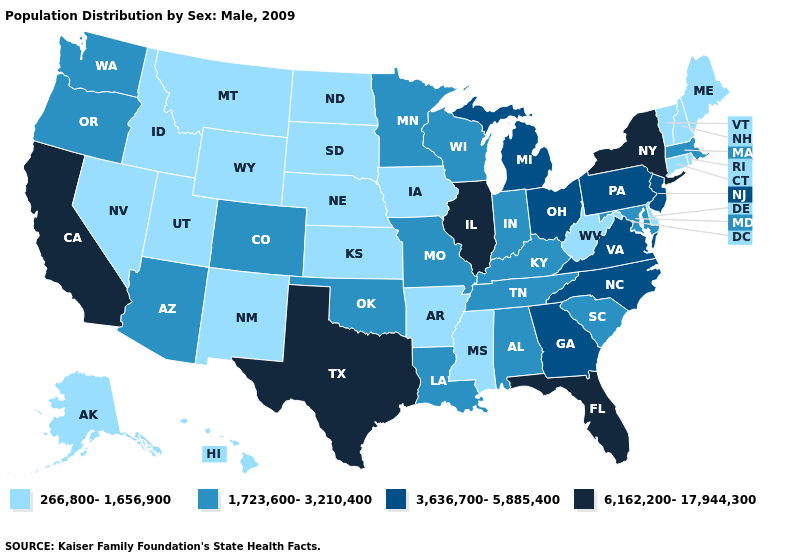Does Texas have the lowest value in the USA?
Quick response, please. No. Does Minnesota have the lowest value in the MidWest?
Quick response, please. No. Among the states that border Virginia , which have the highest value?
Short answer required. North Carolina. What is the value of Alaska?
Short answer required. 266,800-1,656,900. What is the value of South Dakota?
Quick response, please. 266,800-1,656,900. What is the highest value in the USA?
Write a very short answer. 6,162,200-17,944,300. What is the value of Virginia?
Short answer required. 3,636,700-5,885,400. Does the first symbol in the legend represent the smallest category?
Be succinct. Yes. Name the states that have a value in the range 6,162,200-17,944,300?
Give a very brief answer. California, Florida, Illinois, New York, Texas. Name the states that have a value in the range 1,723,600-3,210,400?
Quick response, please. Alabama, Arizona, Colorado, Indiana, Kentucky, Louisiana, Maryland, Massachusetts, Minnesota, Missouri, Oklahoma, Oregon, South Carolina, Tennessee, Washington, Wisconsin. Name the states that have a value in the range 6,162,200-17,944,300?
Write a very short answer. California, Florida, Illinois, New York, Texas. Which states have the lowest value in the USA?
Quick response, please. Alaska, Arkansas, Connecticut, Delaware, Hawaii, Idaho, Iowa, Kansas, Maine, Mississippi, Montana, Nebraska, Nevada, New Hampshire, New Mexico, North Dakota, Rhode Island, South Dakota, Utah, Vermont, West Virginia, Wyoming. Among the states that border Maine , which have the highest value?
Short answer required. New Hampshire. Name the states that have a value in the range 6,162,200-17,944,300?
Quick response, please. California, Florida, Illinois, New York, Texas. Which states have the highest value in the USA?
Short answer required. California, Florida, Illinois, New York, Texas. 